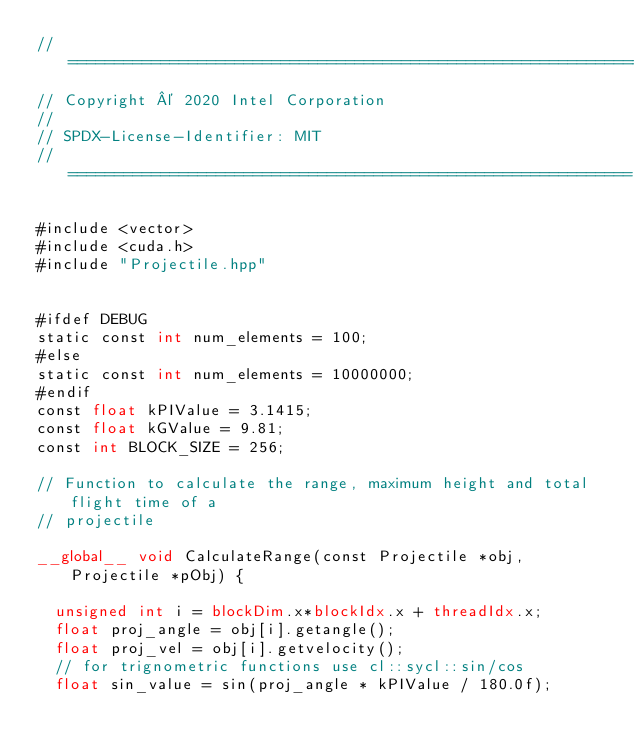Convert code to text. <code><loc_0><loc_0><loc_500><loc_500><_Cuda_>//==============================================================
// Copyright © 2020 Intel Corporation
//
// SPDX-License-Identifier: MIT
// =============================================================

#include <vector>
#include <cuda.h>
#include "Projectile.hpp"


#ifdef DEBUG
static const int num_elements = 100;
#else
static const int num_elements = 10000000;
#endif
const float kPIValue = 3.1415;
const float kGValue = 9.81;
const int BLOCK_SIZE = 256; 

// Function to calculate the range, maximum height and total flight time of a
// projectile

__global__ void CalculateRange(const Projectile *obj, Projectile *pObj) {  
  
  unsigned int i = blockDim.x*blockIdx.x + threadIdx.x;
  float proj_angle = obj[i].getangle();
  float proj_vel = obj[i].getvelocity();
  // for trignometric functions use cl::sycl::sin/cos
  float sin_value = sin(proj_angle * kPIValue / 180.0f);</code> 